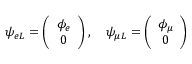Convert formula to latex. <formula><loc_0><loc_0><loc_500><loc_500>\psi _ { e L } = \left ( \begin{array} { c } { { \phi _ { e } } } \\ { 0 } \end{array} \right ) , \quad p s i _ { \mu L } = \left ( \begin{array} { c } { { \phi _ { \mu } } } \\ { 0 } \end{array} \right )</formula> 